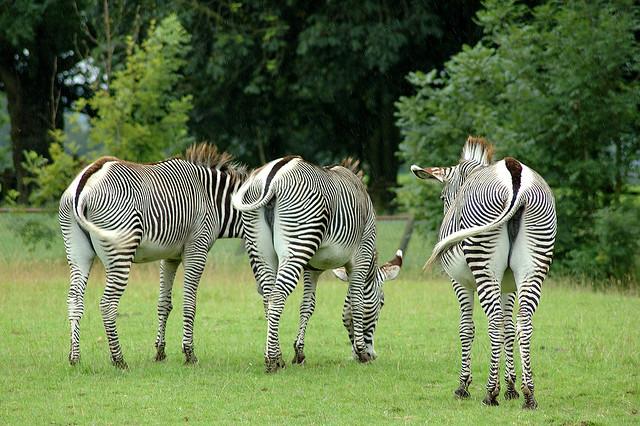What direction are they facing?
Short answer required. Away from camera. How many zebras are there?
Quick response, please. 3. What part of the zebra is facing us?
Keep it brief. Butt. 